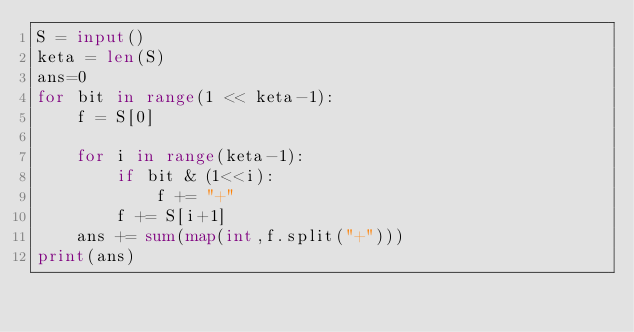<code> <loc_0><loc_0><loc_500><loc_500><_Python_>S = input()
keta = len(S)
ans=0
for bit in range(1 << keta-1):
    f = S[0]

    for i in range(keta-1):
        if bit & (1<<i):
            f += "+"
        f += S[i+1]
    ans += sum(map(int,f.split("+")))
print(ans)</code> 